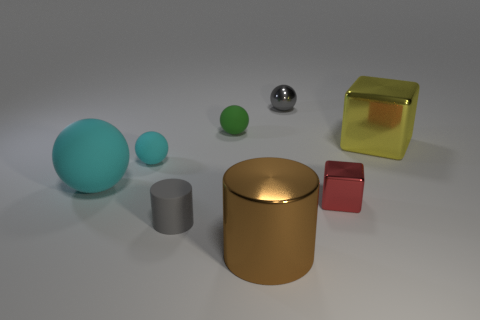What number of metallic spheres have the same color as the rubber cylinder?
Offer a terse response. 1. Are there the same number of matte cylinders right of the red metal cube and big red metal things?
Your response must be concise. Yes. What is the color of the big rubber sphere?
Give a very brief answer. Cyan. There is a gray sphere that is the same material as the large brown object; what is its size?
Provide a succinct answer. Small. What is the color of the big thing that is the same material as the green sphere?
Give a very brief answer. Cyan. Are there any brown metallic cylinders of the same size as the green matte thing?
Make the answer very short. No. What material is the tiny gray object that is the same shape as the tiny cyan thing?
Offer a terse response. Metal. There is a gray metallic thing that is the same size as the gray matte cylinder; what shape is it?
Your response must be concise. Sphere. Is there a yellow metal thing of the same shape as the red object?
Keep it short and to the point. Yes. There is a big shiny object behind the cylinder in front of the tiny gray rubber thing; what is its shape?
Provide a succinct answer. Cube. 